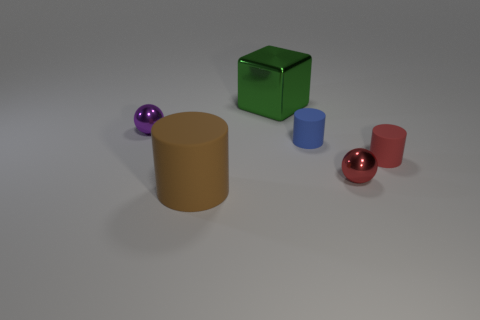Is the large cylinder the same color as the big shiny block?
Ensure brevity in your answer.  No. What material is the large object that is in front of the shiny sphere that is on the left side of the big thing on the right side of the brown matte object?
Your response must be concise. Rubber. What size is the metallic ball that is right of the matte cylinder that is left of the green object?
Your answer should be compact. Small. Is the material of the small blue object the same as the sphere that is on the right side of the big metal cube?
Ensure brevity in your answer.  No. Is the big object that is right of the brown thing made of the same material as the cylinder that is in front of the small red cylinder?
Keep it short and to the point. No. Are there fewer large brown matte things behind the large brown thing than tiny blue things that are in front of the tiny red shiny ball?
Provide a short and direct response. No. How many objects are small purple objects or shiny objects behind the tiny red metal thing?
Provide a succinct answer. 2. What is the material of the other cylinder that is the same size as the blue matte cylinder?
Offer a terse response. Rubber. Is the small blue thing made of the same material as the cube?
Keep it short and to the point. No. There is a rubber object that is left of the tiny red cylinder and behind the brown thing; what color is it?
Ensure brevity in your answer.  Blue. 